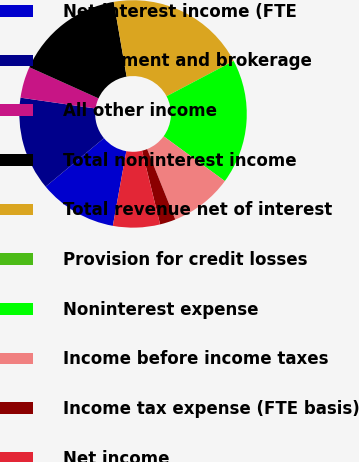Convert chart. <chart><loc_0><loc_0><loc_500><loc_500><pie_chart><fcel>Net interest income (FTE<fcel>Investment and brokerage<fcel>All other income<fcel>Total noninterest income<fcel>Total revenue net of interest<fcel>Provision for credit losses<fcel>Noninterest expense<fcel>Income before income taxes<fcel>Income tax expense (FTE basis)<fcel>Net income<nl><fcel>11.11%<fcel>13.33%<fcel>4.45%<fcel>15.55%<fcel>20.0%<fcel>0.0%<fcel>17.77%<fcel>8.89%<fcel>2.23%<fcel>6.67%<nl></chart> 